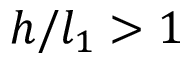<formula> <loc_0><loc_0><loc_500><loc_500>h / l _ { 1 } > 1</formula> 